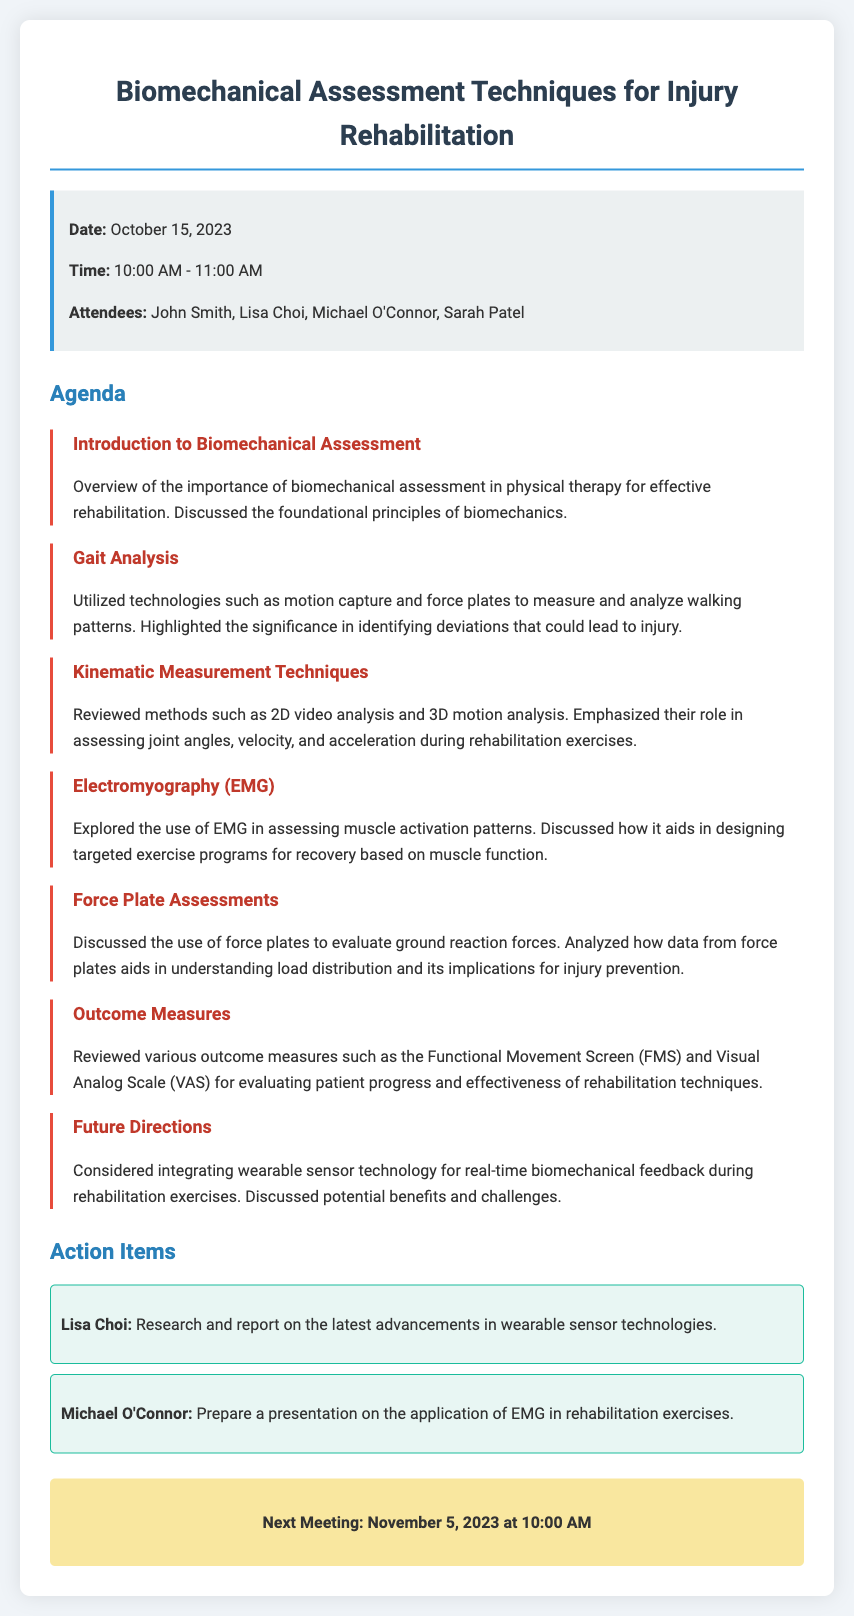What is the date of the meeting? The date of the meeting is specified in the info box of the document.
Answer: October 15, 2023 Who presented on Gait Analysis? The document lists the agenda items, but does not specify who presented on Gait Analysis.
Answer: Not specified Which technology is emphasized for assessing muscle activation patterns? The document mentions Electromyography (EMG) in relation to muscle activation patterns.
Answer: EMG What is the time for the next meeting? The next meeting time is provided in a highlighted section at the end of the document.
Answer: 10:00 AM How many attendees were present at the meeting? The number of attendees is listed in the info box under the attendees section.
Answer: Four What outcome measure was reviewed for evaluating patient progress? The document lists outcome measures such as the Functional Movement Screen (FMS) and Visual Analog Scale (VAS).
Answer: FMS and VAS What action item was assigned to Lisa Choi? The document states specific action items assigned to attendees.
Answer: Research and report on the latest advancements in wearable sensor technologies What is the role of force plates according to the document? The document discusses the use of force plates in evaluating ground reaction forces.
Answer: Evaluate ground reaction forces Which two types of kinematic measurement techniques were mentioned? The document lists methods under kinematic measurement techniques in the agenda.
Answer: 2D video analysis and 3D motion analysis 